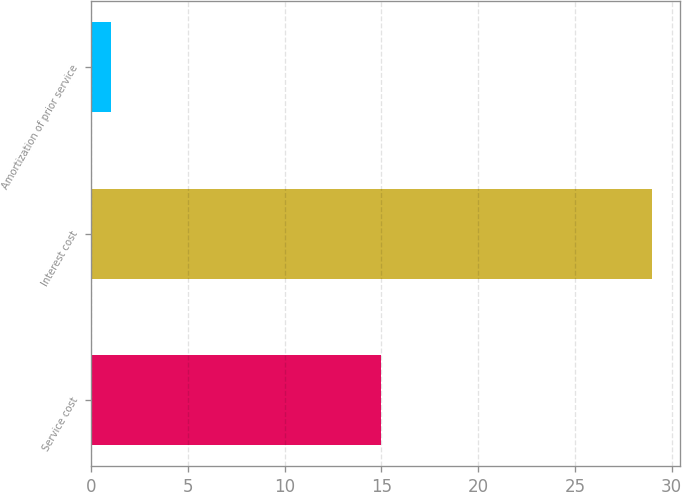Convert chart. <chart><loc_0><loc_0><loc_500><loc_500><bar_chart><fcel>Service cost<fcel>Interest cost<fcel>Amortization of prior service<nl><fcel>15<fcel>29<fcel>1<nl></chart> 